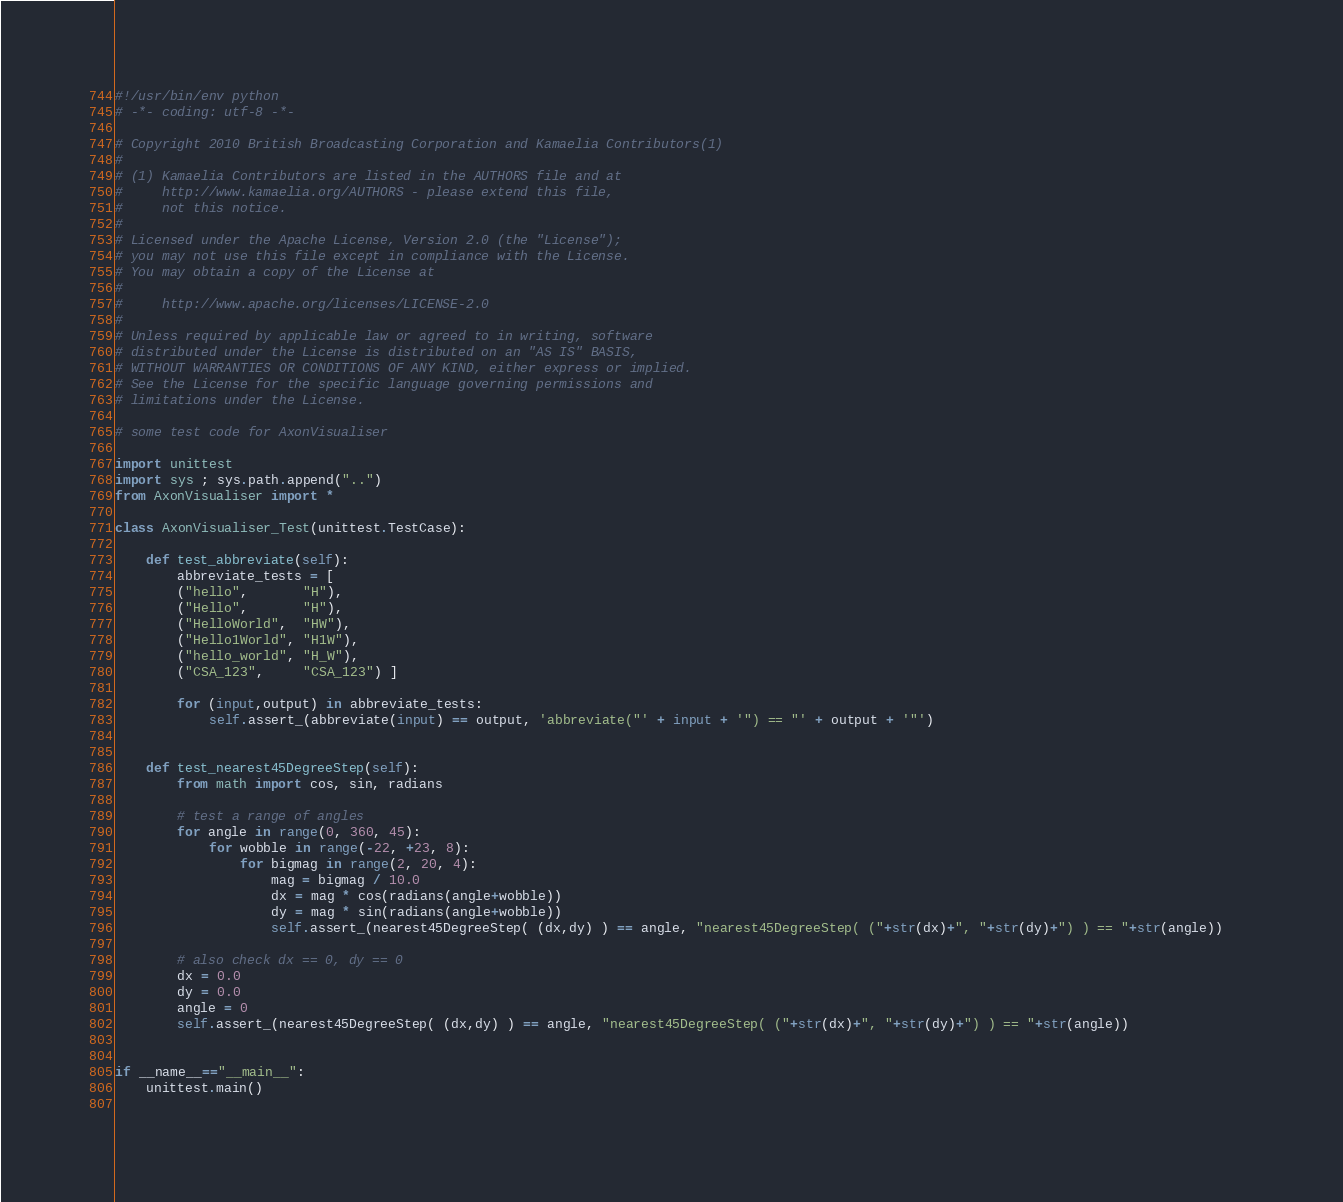Convert code to text. <code><loc_0><loc_0><loc_500><loc_500><_Python_>#!/usr/bin/env python
# -*- coding: utf-8 -*-

# Copyright 2010 British Broadcasting Corporation and Kamaelia Contributors(1)
#
# (1) Kamaelia Contributors are listed in the AUTHORS file and at
#     http://www.kamaelia.org/AUTHORS - please extend this file,
#     not this notice.
#
# Licensed under the Apache License, Version 2.0 (the "License");
# you may not use this file except in compliance with the License.
# You may obtain a copy of the License at
#
#     http://www.apache.org/licenses/LICENSE-2.0
#
# Unless required by applicable law or agreed to in writing, software
# distributed under the License is distributed on an "AS IS" BASIS,
# WITHOUT WARRANTIES OR CONDITIONS OF ANY KIND, either express or implied.
# See the License for the specific language governing permissions and
# limitations under the License.

# some test code for AxonVisualiser

import unittest
import sys ; sys.path.append("..")
from AxonVisualiser import *

class AxonVisualiser_Test(unittest.TestCase):

    def test_abbreviate(self):
        abbreviate_tests = [
        ("hello",       "H"),
        ("Hello",       "H"),
        ("HelloWorld",  "HW"),
        ("Hello1World", "H1W"),
        ("hello_world", "H_W"),
        ("CSA_123",     "CSA_123") ]
        
        for (input,output) in abbreviate_tests:
            self.assert_(abbreviate(input) == output, 'abbreviate("' + input + '") == "' + output + '"')

            
    def test_nearest45DegreeStep(self):
        from math import cos, sin, radians
        
        # test a range of angles
        for angle in range(0, 360, 45):
            for wobble in range(-22, +23, 8):
                for bigmag in range(2, 20, 4):
                    mag = bigmag / 10.0
                    dx = mag * cos(radians(angle+wobble))
                    dy = mag * sin(radians(angle+wobble))
                    self.assert_(nearest45DegreeStep( (dx,dy) ) == angle, "nearest45DegreeStep( ("+str(dx)+", "+str(dy)+") ) == "+str(angle))
                    
        # also check dx == 0, dy == 0
        dx = 0.0
        dy = 0.0
        angle = 0
        self.assert_(nearest45DegreeStep( (dx,dy) ) == angle, "nearest45DegreeStep( ("+str(dx)+", "+str(dy)+") ) == "+str(angle))                
        
        
if __name__=="__main__":
    unittest.main()
    </code> 